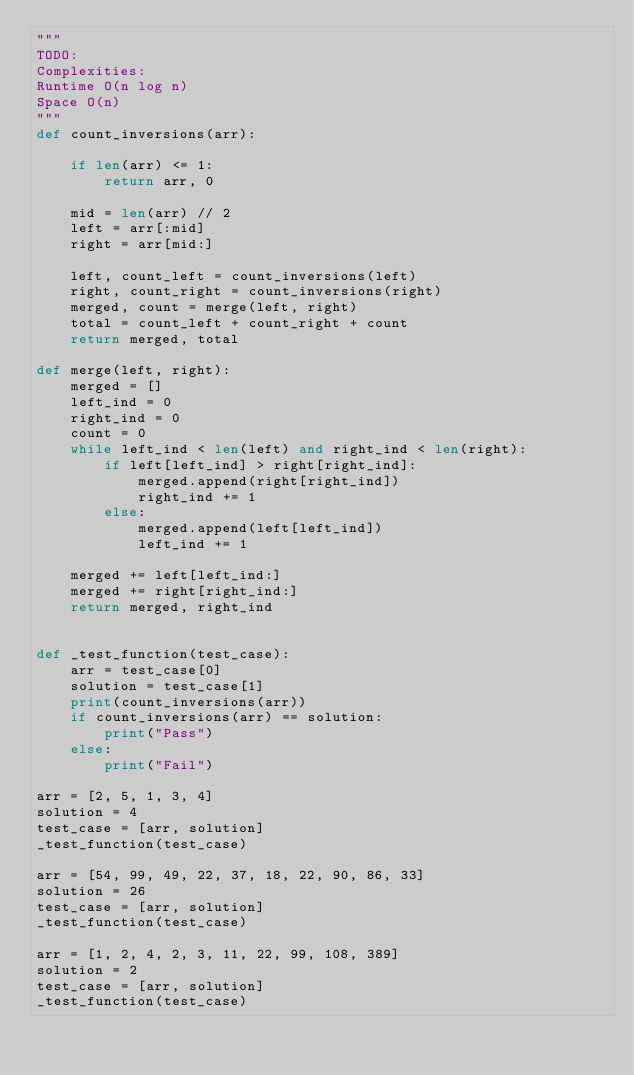Convert code to text. <code><loc_0><loc_0><loc_500><loc_500><_Python_>"""
TODO:
Complexities:
Runtime O(n log n)
Space O(n)
"""
def count_inversions(arr):

    if len(arr) <= 1:
        return arr, 0

    mid = len(arr) // 2
    left = arr[:mid]
    right = arr[mid:]

    left, count_left = count_inversions(left)
    right, count_right = count_inversions(right)
    merged, count = merge(left, right)
    total = count_left + count_right + count
    return merged, total

def merge(left, right):
    merged = []
    left_ind = 0
    right_ind = 0
    count = 0
    while left_ind < len(left) and right_ind < len(right):
        if left[left_ind] > right[right_ind]:
            merged.append(right[right_ind])
            right_ind += 1
        else:
            merged.append(left[left_ind])
            left_ind += 1

    merged += left[left_ind:]
    merged += right[right_ind:]
    return merged, right_ind


def _test_function(test_case):
    arr = test_case[0]
    solution = test_case[1]
    print(count_inversions(arr))
    if count_inversions(arr) == solution:
        print("Pass")
    else:
        print("Fail")

arr = [2, 5, 1, 3, 4]
solution = 4
test_case = [arr, solution]
_test_function(test_case)

arr = [54, 99, 49, 22, 37, 18, 22, 90, 86, 33]
solution = 26
test_case = [arr, solution]
_test_function(test_case)

arr = [1, 2, 4, 2, 3, 11, 22, 99, 108, 389]
solution = 2
test_case = [arr, solution]
_test_function(test_case)</code> 